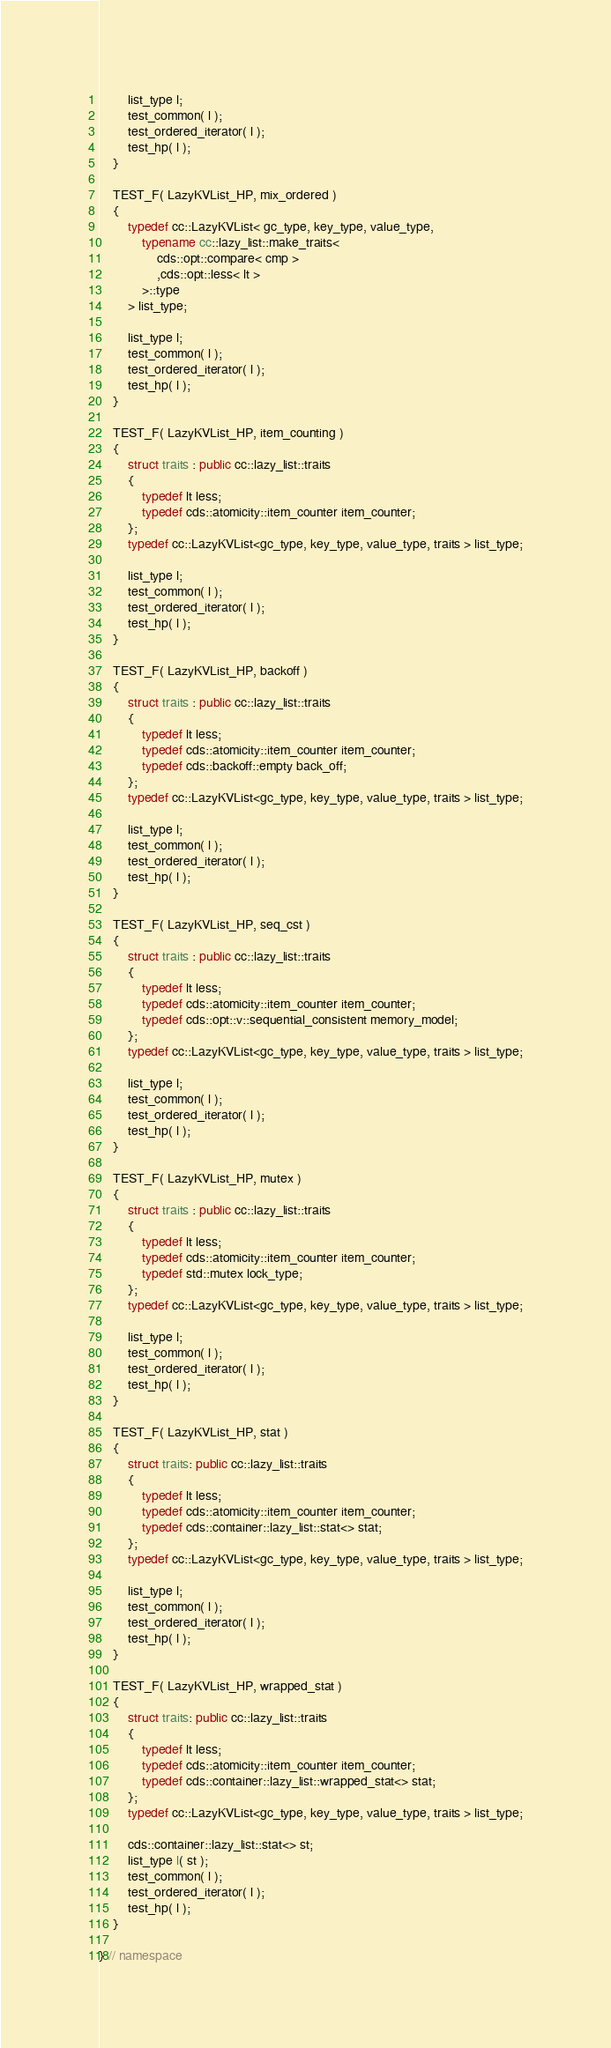Convert code to text. <code><loc_0><loc_0><loc_500><loc_500><_C++_>
        list_type l;
        test_common( l );
        test_ordered_iterator( l );
        test_hp( l );
    }

    TEST_F( LazyKVList_HP, mix_ordered )
    {
        typedef cc::LazyKVList< gc_type, key_type, value_type,
            typename cc::lazy_list::make_traits<
                cds::opt::compare< cmp >
                ,cds::opt::less< lt >
            >::type
        > list_type;

        list_type l;
        test_common( l );
        test_ordered_iterator( l );
        test_hp( l );
    }

    TEST_F( LazyKVList_HP, item_counting )
    {
        struct traits : public cc::lazy_list::traits
        {
            typedef lt less;
            typedef cds::atomicity::item_counter item_counter;
        };
        typedef cc::LazyKVList<gc_type, key_type, value_type, traits > list_type;

        list_type l;
        test_common( l );
        test_ordered_iterator( l );
        test_hp( l );
    }

    TEST_F( LazyKVList_HP, backoff )
    {
        struct traits : public cc::lazy_list::traits
        {
            typedef lt less;
            typedef cds::atomicity::item_counter item_counter;
            typedef cds::backoff::empty back_off;
        };
        typedef cc::LazyKVList<gc_type, key_type, value_type, traits > list_type;

        list_type l;
        test_common( l );
        test_ordered_iterator( l );
        test_hp( l );
    }

    TEST_F( LazyKVList_HP, seq_cst )
    {
        struct traits : public cc::lazy_list::traits
        {
            typedef lt less;
            typedef cds::atomicity::item_counter item_counter;
            typedef cds::opt::v::sequential_consistent memory_model;
        };
        typedef cc::LazyKVList<gc_type, key_type, value_type, traits > list_type;

        list_type l;
        test_common( l );
        test_ordered_iterator( l );
        test_hp( l );
    }

    TEST_F( LazyKVList_HP, mutex )
    {
        struct traits : public cc::lazy_list::traits
        {
            typedef lt less;
            typedef cds::atomicity::item_counter item_counter;
            typedef std::mutex lock_type;
        };
        typedef cc::LazyKVList<gc_type, key_type, value_type, traits > list_type;

        list_type l;
        test_common( l );
        test_ordered_iterator( l );
        test_hp( l );
    }

    TEST_F( LazyKVList_HP, stat )
    {
        struct traits: public cc::lazy_list::traits
        {
            typedef lt less;
            typedef cds::atomicity::item_counter item_counter;
            typedef cds::container::lazy_list::stat<> stat;
        };
        typedef cc::LazyKVList<gc_type, key_type, value_type, traits > list_type;

        list_type l;
        test_common( l );
        test_ordered_iterator( l );
        test_hp( l );
    }

    TEST_F( LazyKVList_HP, wrapped_stat )
    {
        struct traits: public cc::lazy_list::traits
        {
            typedef lt less;
            typedef cds::atomicity::item_counter item_counter;
            typedef cds::container::lazy_list::wrapped_stat<> stat;
        };
        typedef cc::LazyKVList<gc_type, key_type, value_type, traits > list_type;

        cds::container::lazy_list::stat<> st;
        list_type l( st );
        test_common( l );
        test_ordered_iterator( l );
        test_hp( l );
    }

} // namespace
</code> 